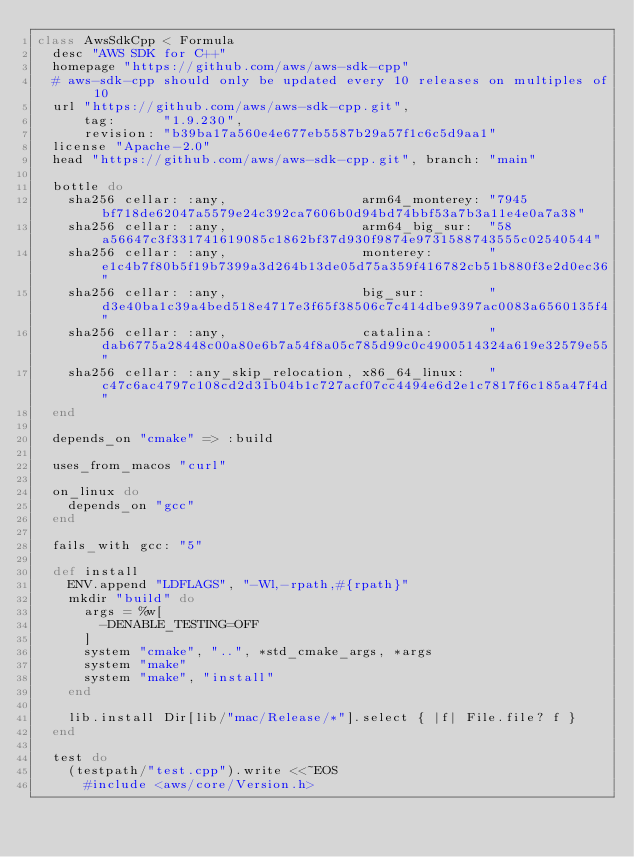<code> <loc_0><loc_0><loc_500><loc_500><_Ruby_>class AwsSdkCpp < Formula
  desc "AWS SDK for C++"
  homepage "https://github.com/aws/aws-sdk-cpp"
  # aws-sdk-cpp should only be updated every 10 releases on multiples of 10
  url "https://github.com/aws/aws-sdk-cpp.git",
      tag:      "1.9.230",
      revision: "b39ba17a560e4e677eb5587b29a57f1c6c5d9aa1"
  license "Apache-2.0"
  head "https://github.com/aws/aws-sdk-cpp.git", branch: "main"

  bottle do
    sha256 cellar: :any,                 arm64_monterey: "7945bf718de62047a5579e24c392ca7606b0d94bd74bbf53a7b3a11e4e0a7a38"
    sha256 cellar: :any,                 arm64_big_sur:  "58a56647c3f331741619085c1862bf37d930f9874e9731588743555c02540544"
    sha256 cellar: :any,                 monterey:       "e1c4b7f80b5f19b7399a3d264b13de05d75a359f416782cb51b880f3e2d0ec36"
    sha256 cellar: :any,                 big_sur:        "d3e40ba1c39a4bed518e4717e3f65f38506c7c414dbe9397ac0083a6560135f4"
    sha256 cellar: :any,                 catalina:       "dab6775a28448c00a80e6b7a54f8a05c785d99c0c4900514324a619e32579e55"
    sha256 cellar: :any_skip_relocation, x86_64_linux:   "c47c6ac4797c108cd2d31b04b1c727acf07cc4494e6d2e1c7817f6c185a47f4d"
  end

  depends_on "cmake" => :build

  uses_from_macos "curl"

  on_linux do
    depends_on "gcc"
  end

  fails_with gcc: "5"

  def install
    ENV.append "LDFLAGS", "-Wl,-rpath,#{rpath}"
    mkdir "build" do
      args = %w[
        -DENABLE_TESTING=OFF
      ]
      system "cmake", "..", *std_cmake_args, *args
      system "make"
      system "make", "install"
    end

    lib.install Dir[lib/"mac/Release/*"].select { |f| File.file? f }
  end

  test do
    (testpath/"test.cpp").write <<~EOS
      #include <aws/core/Version.h></code> 